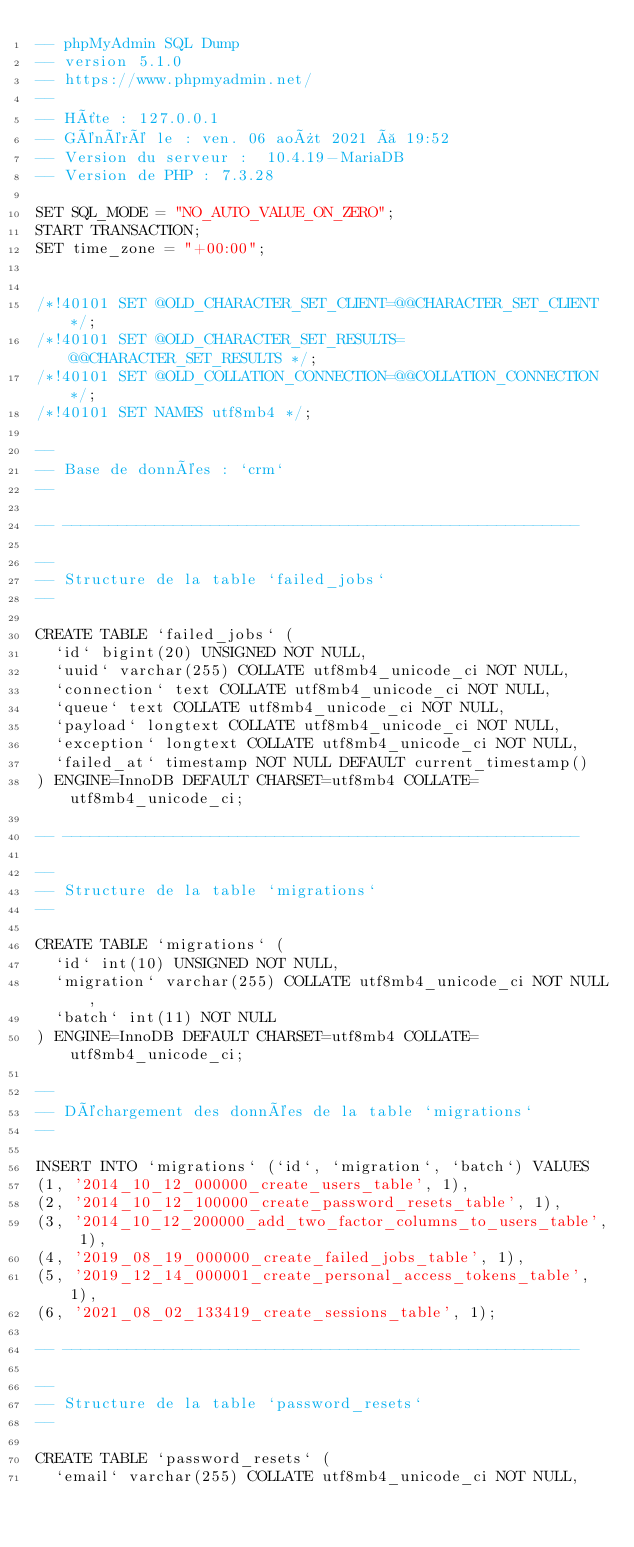Convert code to text. <code><loc_0><loc_0><loc_500><loc_500><_SQL_>-- phpMyAdmin SQL Dump
-- version 5.1.0
-- https://www.phpmyadmin.net/
--
-- Hôte : 127.0.0.1
-- Généré le : ven. 06 août 2021 à 19:52
-- Version du serveur :  10.4.19-MariaDB
-- Version de PHP : 7.3.28

SET SQL_MODE = "NO_AUTO_VALUE_ON_ZERO";
START TRANSACTION;
SET time_zone = "+00:00";


/*!40101 SET @OLD_CHARACTER_SET_CLIENT=@@CHARACTER_SET_CLIENT */;
/*!40101 SET @OLD_CHARACTER_SET_RESULTS=@@CHARACTER_SET_RESULTS */;
/*!40101 SET @OLD_COLLATION_CONNECTION=@@COLLATION_CONNECTION */;
/*!40101 SET NAMES utf8mb4 */;

--
-- Base de données : `crm`
--

-- --------------------------------------------------------

--
-- Structure de la table `failed_jobs`
--

CREATE TABLE `failed_jobs` (
  `id` bigint(20) UNSIGNED NOT NULL,
  `uuid` varchar(255) COLLATE utf8mb4_unicode_ci NOT NULL,
  `connection` text COLLATE utf8mb4_unicode_ci NOT NULL,
  `queue` text COLLATE utf8mb4_unicode_ci NOT NULL,
  `payload` longtext COLLATE utf8mb4_unicode_ci NOT NULL,
  `exception` longtext COLLATE utf8mb4_unicode_ci NOT NULL,
  `failed_at` timestamp NOT NULL DEFAULT current_timestamp()
) ENGINE=InnoDB DEFAULT CHARSET=utf8mb4 COLLATE=utf8mb4_unicode_ci;

-- --------------------------------------------------------

--
-- Structure de la table `migrations`
--

CREATE TABLE `migrations` (
  `id` int(10) UNSIGNED NOT NULL,
  `migration` varchar(255) COLLATE utf8mb4_unicode_ci NOT NULL,
  `batch` int(11) NOT NULL
) ENGINE=InnoDB DEFAULT CHARSET=utf8mb4 COLLATE=utf8mb4_unicode_ci;

--
-- Déchargement des données de la table `migrations`
--

INSERT INTO `migrations` (`id`, `migration`, `batch`) VALUES
(1, '2014_10_12_000000_create_users_table', 1),
(2, '2014_10_12_100000_create_password_resets_table', 1),
(3, '2014_10_12_200000_add_two_factor_columns_to_users_table', 1),
(4, '2019_08_19_000000_create_failed_jobs_table', 1),
(5, '2019_12_14_000001_create_personal_access_tokens_table', 1),
(6, '2021_08_02_133419_create_sessions_table', 1);

-- --------------------------------------------------------

--
-- Structure de la table `password_resets`
--

CREATE TABLE `password_resets` (
  `email` varchar(255) COLLATE utf8mb4_unicode_ci NOT NULL,</code> 